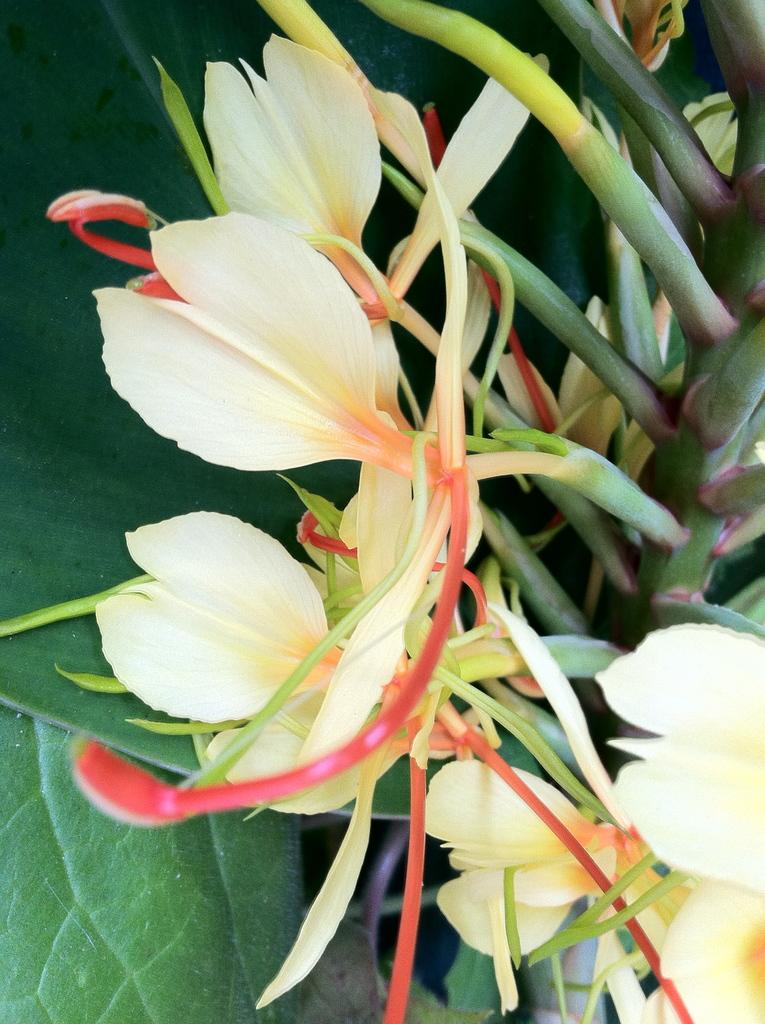What type of plant life is present in the image? There are flowers in the image. What parts of the flowers are visible in the image? Stems and leaves are visible in the image. What month is depicted in the image? There is no specific month depicted in the image, as it features flowers, stems, and leaves, which can be found throughout various months of the year. 